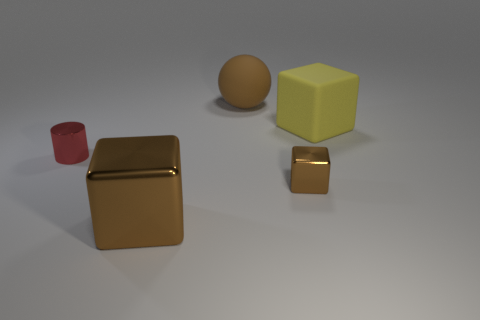Add 5 blue balls. How many objects exist? 10 Subtract all spheres. How many objects are left? 4 Add 3 tiny red objects. How many tiny red objects are left? 4 Add 3 large cubes. How many large cubes exist? 5 Subtract 0 purple balls. How many objects are left? 5 Subtract all large gray cylinders. Subtract all brown shiny objects. How many objects are left? 3 